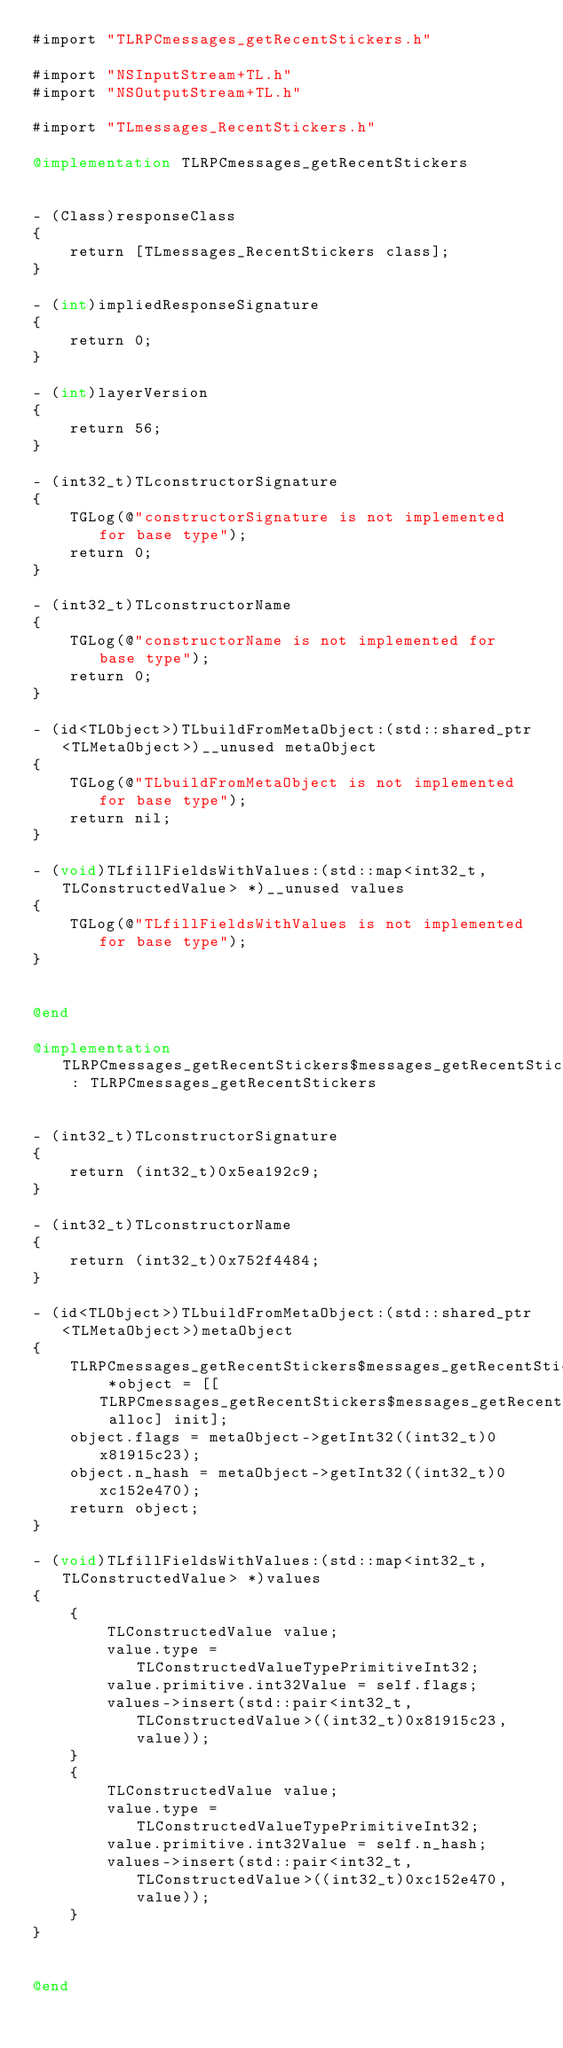Convert code to text. <code><loc_0><loc_0><loc_500><loc_500><_ObjectiveC_>#import "TLRPCmessages_getRecentStickers.h"

#import "NSInputStream+TL.h"
#import "NSOutputStream+TL.h"

#import "TLmessages_RecentStickers.h"

@implementation TLRPCmessages_getRecentStickers


- (Class)responseClass
{
    return [TLmessages_RecentStickers class];
}

- (int)impliedResponseSignature
{
    return 0;
}

- (int)layerVersion
{
    return 56;
}

- (int32_t)TLconstructorSignature
{
    TGLog(@"constructorSignature is not implemented for base type");
    return 0;
}

- (int32_t)TLconstructorName
{
    TGLog(@"constructorName is not implemented for base type");
    return 0;
}

- (id<TLObject>)TLbuildFromMetaObject:(std::shared_ptr<TLMetaObject>)__unused metaObject
{
    TGLog(@"TLbuildFromMetaObject is not implemented for base type");
    return nil;
}

- (void)TLfillFieldsWithValues:(std::map<int32_t, TLConstructedValue> *)__unused values
{
    TGLog(@"TLfillFieldsWithValues is not implemented for base type");
}


@end

@implementation TLRPCmessages_getRecentStickers$messages_getRecentStickers : TLRPCmessages_getRecentStickers


- (int32_t)TLconstructorSignature
{
    return (int32_t)0x5ea192c9;
}

- (int32_t)TLconstructorName
{
    return (int32_t)0x752f4484;
}

- (id<TLObject>)TLbuildFromMetaObject:(std::shared_ptr<TLMetaObject>)metaObject
{
    TLRPCmessages_getRecentStickers$messages_getRecentStickers *object = [[TLRPCmessages_getRecentStickers$messages_getRecentStickers alloc] init];
    object.flags = metaObject->getInt32((int32_t)0x81915c23);
    object.n_hash = metaObject->getInt32((int32_t)0xc152e470);
    return object;
}

- (void)TLfillFieldsWithValues:(std::map<int32_t, TLConstructedValue> *)values
{
    {
        TLConstructedValue value;
        value.type = TLConstructedValueTypePrimitiveInt32;
        value.primitive.int32Value = self.flags;
        values->insert(std::pair<int32_t, TLConstructedValue>((int32_t)0x81915c23, value));
    }
    {
        TLConstructedValue value;
        value.type = TLConstructedValueTypePrimitiveInt32;
        value.primitive.int32Value = self.n_hash;
        values->insert(std::pair<int32_t, TLConstructedValue>((int32_t)0xc152e470, value));
    }
}


@end

</code> 